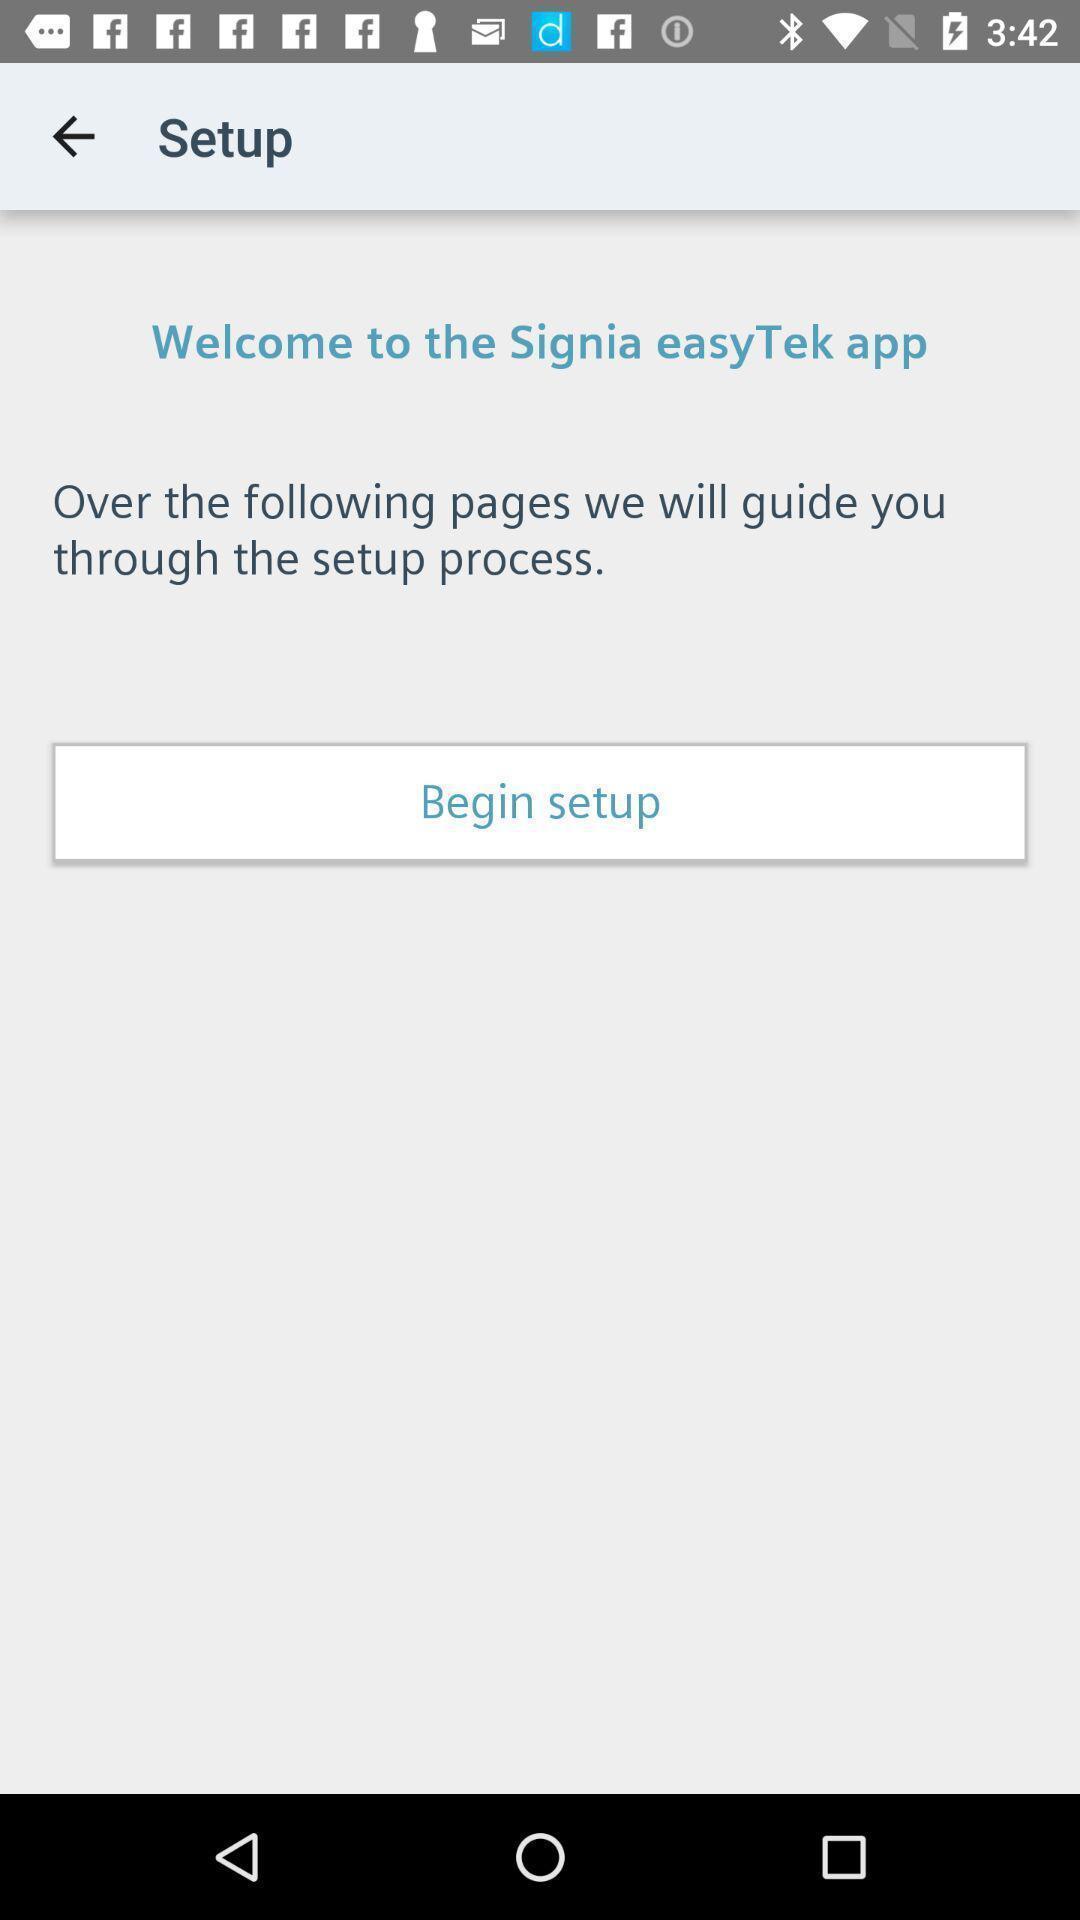Give me a narrative description of this picture. Welcome page of technology app with begin setup tab. 